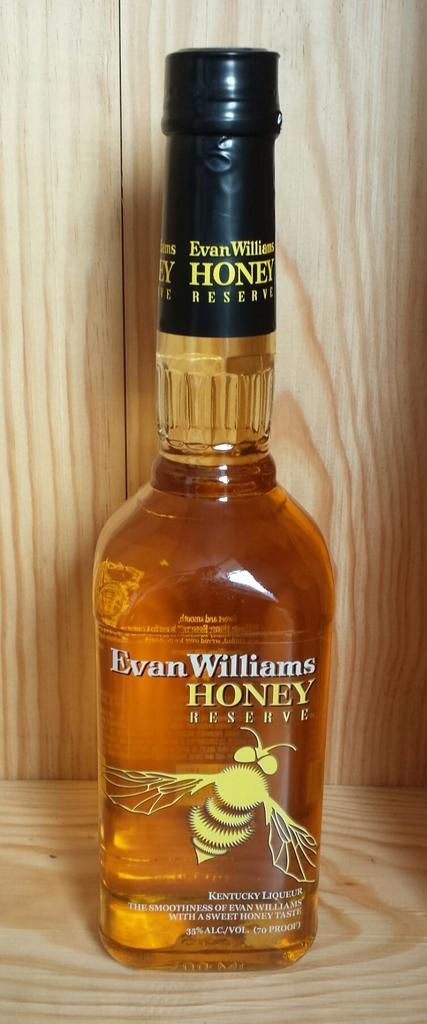What is the main object in the image? There is a bottle of honey in the image. Where is the bottle of honey located? The bottle of honey is placed on a table. What can be seen on the bottle of honey? The bottle of honey has a picture of a honey bee on it. What is the title of the book on the roof in the image? There is no book or roof present in the image; it only features a bottle of honey on a table. 